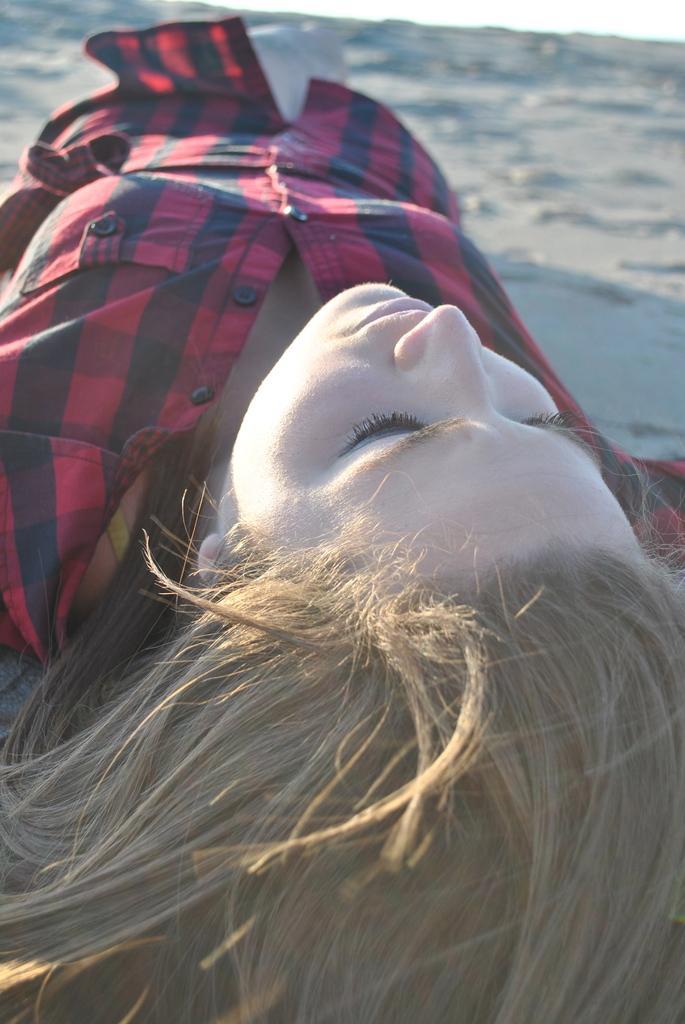Describe this image in one or two sentences. In this picture there is a girl in the center of the image, she is lying on the muddy floor. 